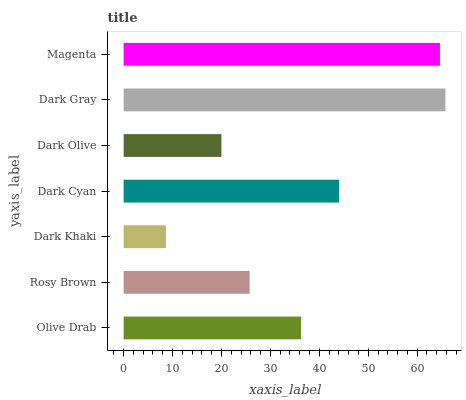Is Dark Khaki the minimum?
Answer yes or no. Yes. Is Dark Gray the maximum?
Answer yes or no. Yes. Is Rosy Brown the minimum?
Answer yes or no. No. Is Rosy Brown the maximum?
Answer yes or no. No. Is Olive Drab greater than Rosy Brown?
Answer yes or no. Yes. Is Rosy Brown less than Olive Drab?
Answer yes or no. Yes. Is Rosy Brown greater than Olive Drab?
Answer yes or no. No. Is Olive Drab less than Rosy Brown?
Answer yes or no. No. Is Olive Drab the high median?
Answer yes or no. Yes. Is Olive Drab the low median?
Answer yes or no. Yes. Is Magenta the high median?
Answer yes or no. No. Is Dark Khaki the low median?
Answer yes or no. No. 